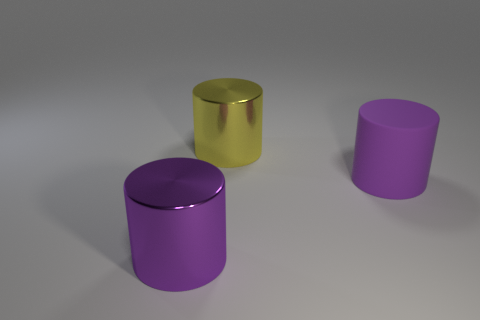Add 3 small purple metal cylinders. How many objects exist? 6 Add 1 large purple rubber objects. How many large purple rubber objects are left? 2 Add 3 small balls. How many small balls exist? 3 Subtract 0 red cylinders. How many objects are left? 3 Subtract all yellow metal cylinders. Subtract all large purple shiny objects. How many objects are left? 1 